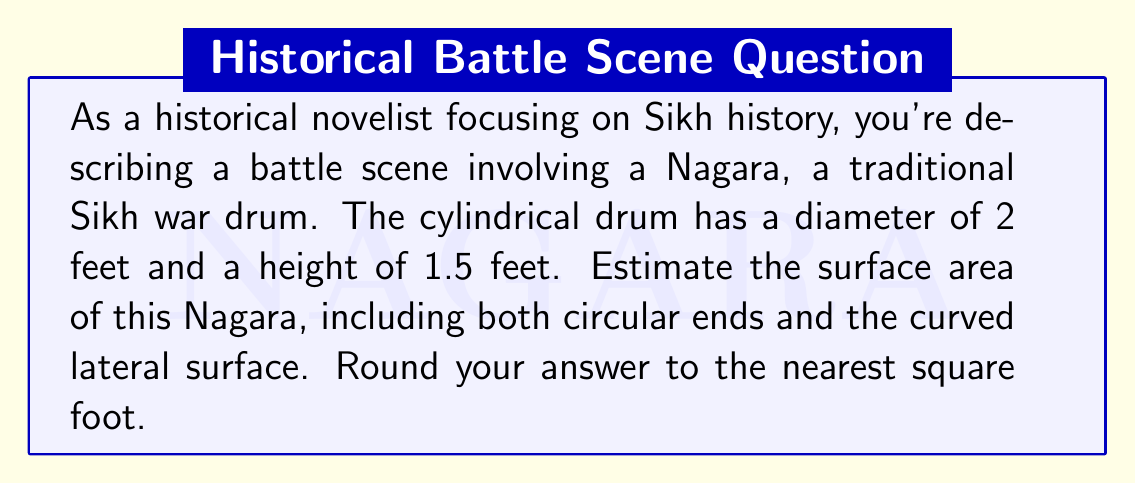Teach me how to tackle this problem. To estimate the surface area of a cylindrical Sikh war drum (Nagara), we need to calculate the area of three parts: two circular ends and the curved lateral surface. Let's break it down step-by-step:

1. Given dimensions:
   Diameter (d) = 2 feet
   Height (h) = 1.5 feet
   Radius (r) = d/2 = 1 foot

2. Area of one circular end:
   $$A_{circle} = \pi r^2 = \pi (1 \text{ ft})^2 = \pi \text{ sq ft}$$

3. Area of both circular ends:
   $$A_{ends} = 2\pi r^2 = 2\pi \text{ sq ft}$$

4. Area of the curved lateral surface:
   The lateral surface area of a cylinder is given by the formula:
   $$A_{lateral} = 2\pi rh$$
   $$A_{lateral} = 2\pi (1 \text{ ft})(1.5 \text{ ft}) = 3\pi \text{ sq ft}$$

5. Total surface area:
   $$A_{total} = A_{ends} + A_{lateral} = 2\pi \text{ sq ft} + 3\pi \text{ sq ft} = 5\pi \text{ sq ft}$$

6. Calculate the numerical value:
   $$A_{total} = 5\pi \approx 15.71 \text{ sq ft}$$

7. Rounding to the nearest square foot:
   15.71 sq ft rounds to 16 sq ft

[asy]
import geometry;

size(200);
real r = 1;
real h = 1.5;

path p = circle((0,0),r);
path q = circle((0,h),r);

draw(p);
draw(q);
draw((r,0)--(r,h));
draw((-r,0)--(-r,h));
draw((0,0)--(0,h),dashed);
draw((0,0)--(r,0),Arrow);

label("r", (r/2,0), S);
label("h", (r,h/2), E);

</asy>
Answer: The estimated surface area of the cylindrical Sikh war drum (Nagara) is approximately 16 square feet. 